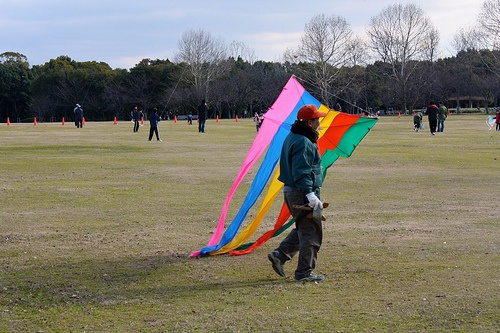Describe the objects in this image and their specific colors. I can see kite in lavender, gray, violet, lightblue, and red tones, people in lavender, black, gray, blue, and darkblue tones, people in lavender, black, tan, darkgray, and gray tones, people in lavender, black, gray, and darkgray tones, and people in lavender, black, gray, maroon, and darkgray tones in this image. 